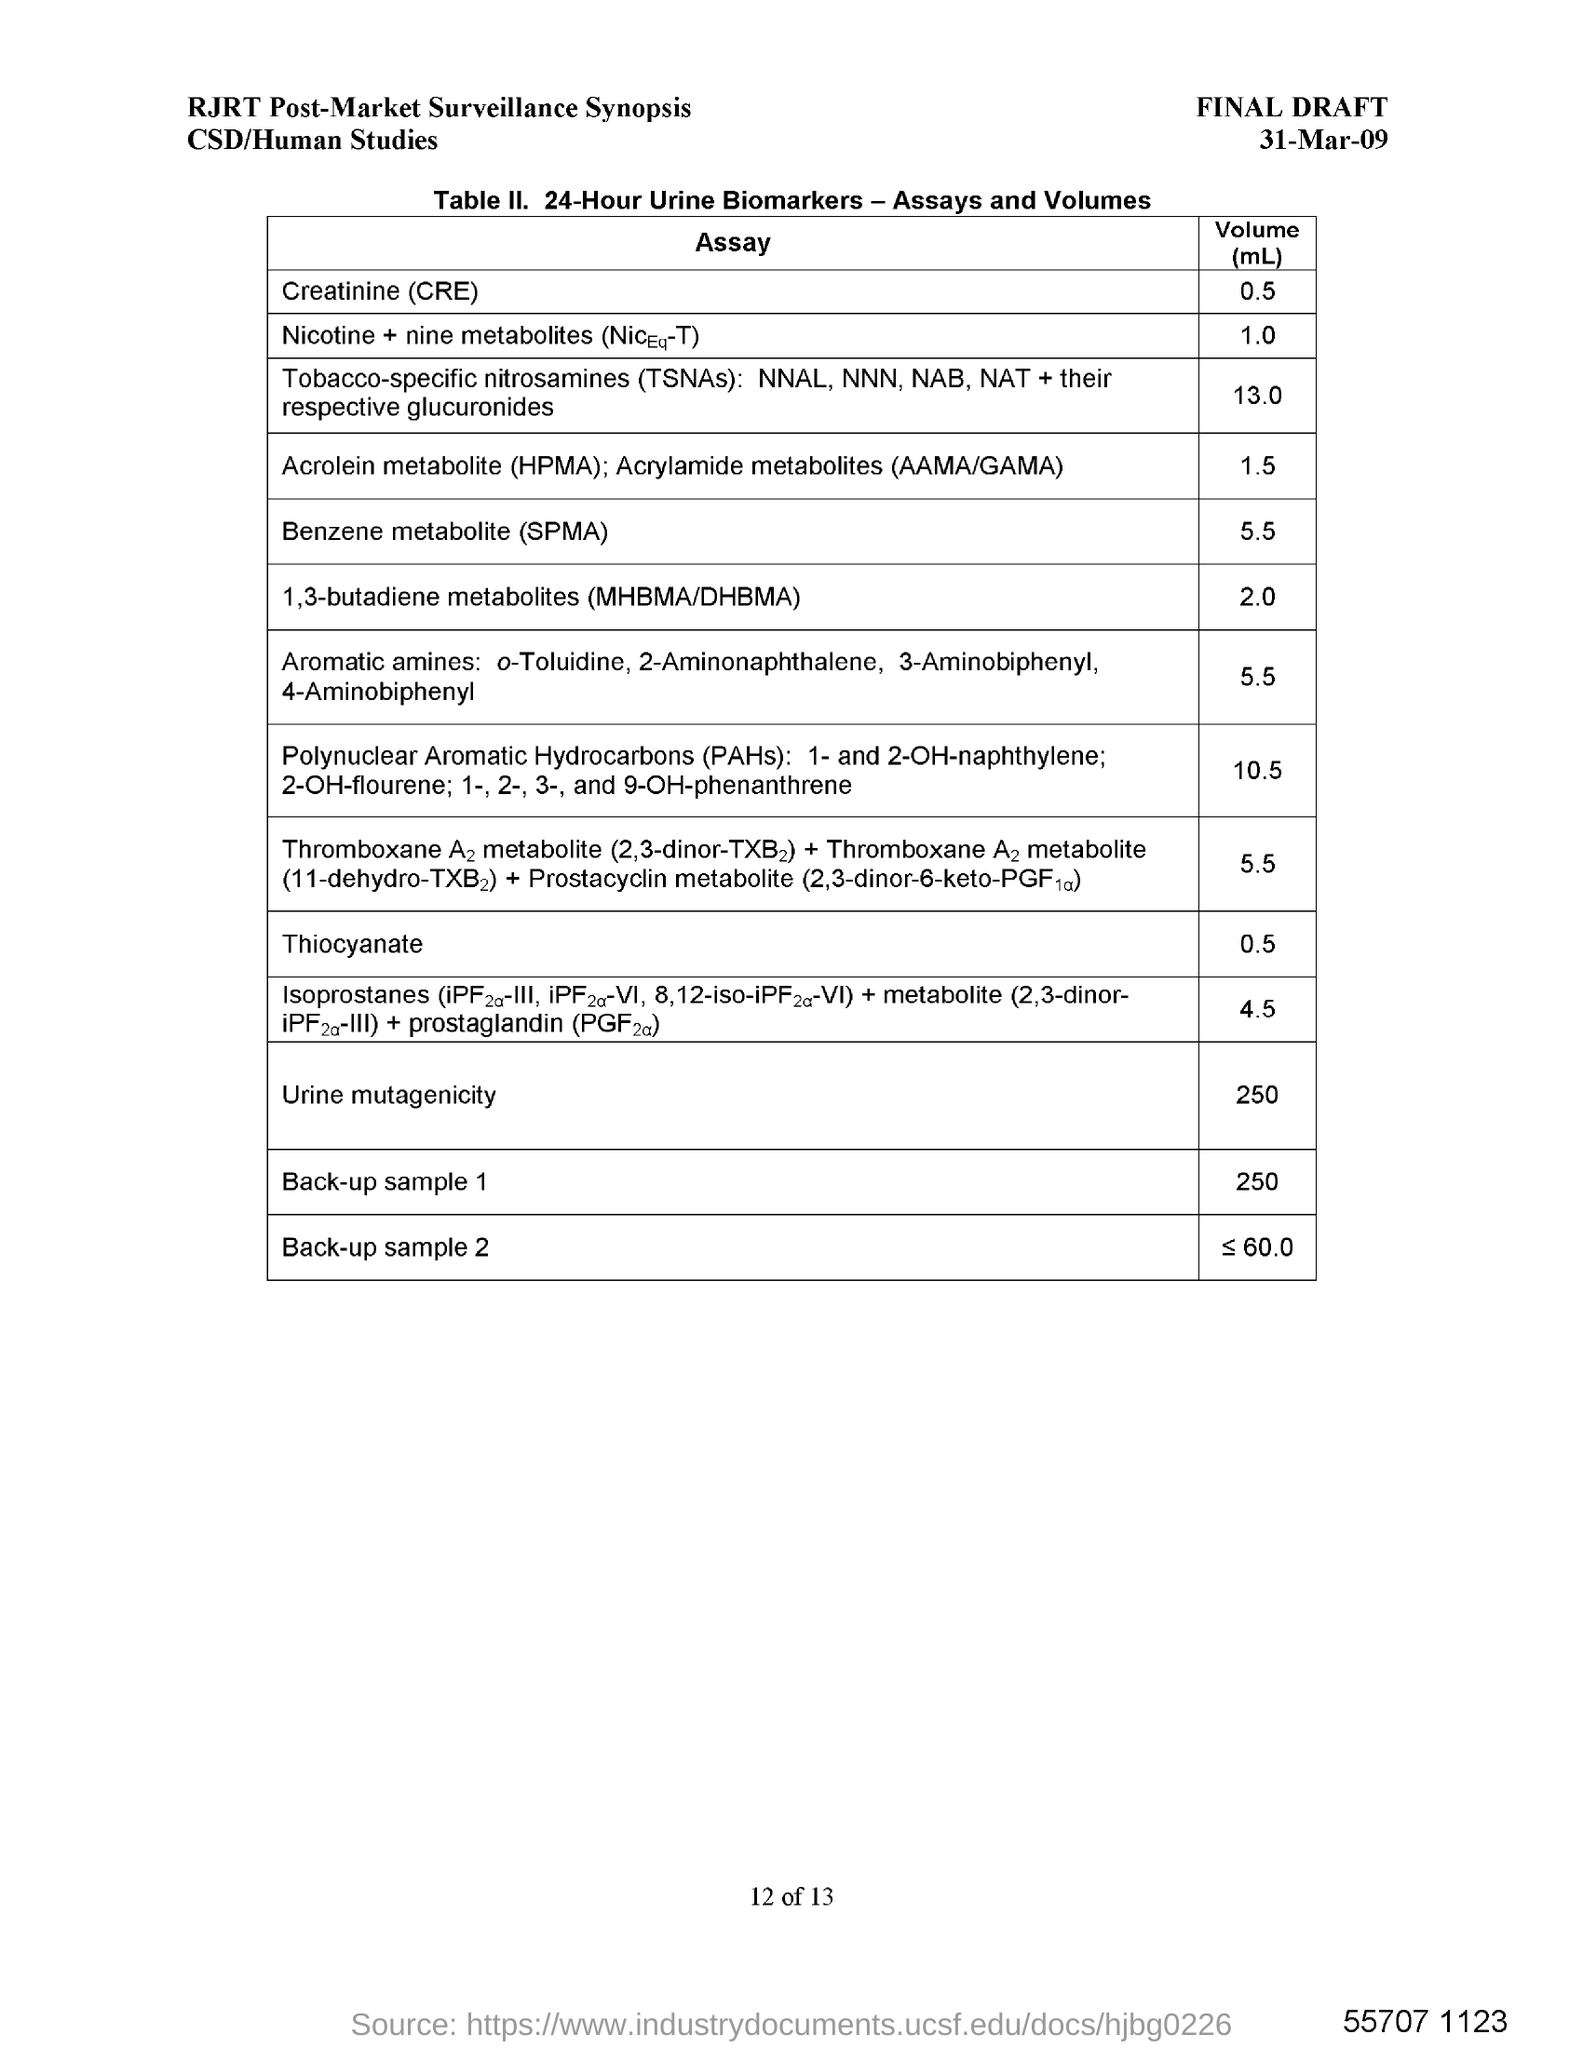Point out several critical features in this image. The date in the draft is 31 March 2009. 